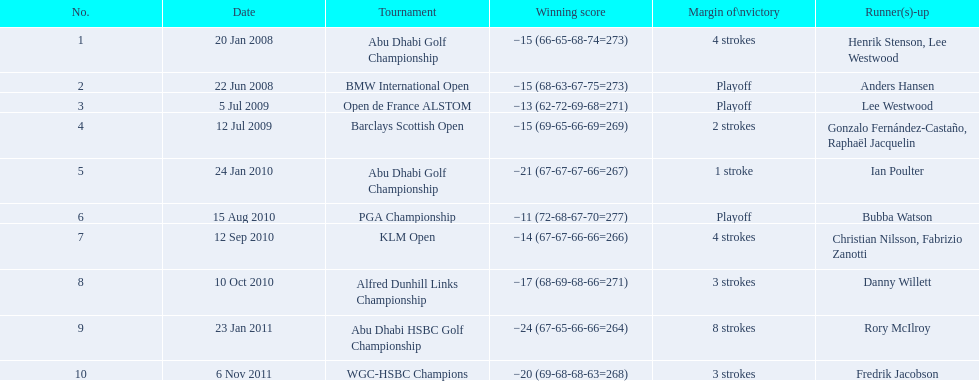How many total tournaments has he won? 10. 